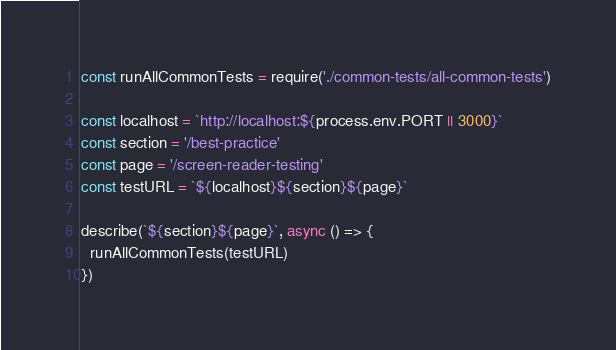Convert code to text. <code><loc_0><loc_0><loc_500><loc_500><_JavaScript_>const runAllCommonTests = require('./common-tests/all-common-tests')

const localhost = `http://localhost:${process.env.PORT || 3000}`
const section = '/best-practice'
const page = '/screen-reader-testing'
const testURL = `${localhost}${section}${page}`

describe(`${section}${page}`, async () => {
  runAllCommonTests(testURL)
})
</code> 